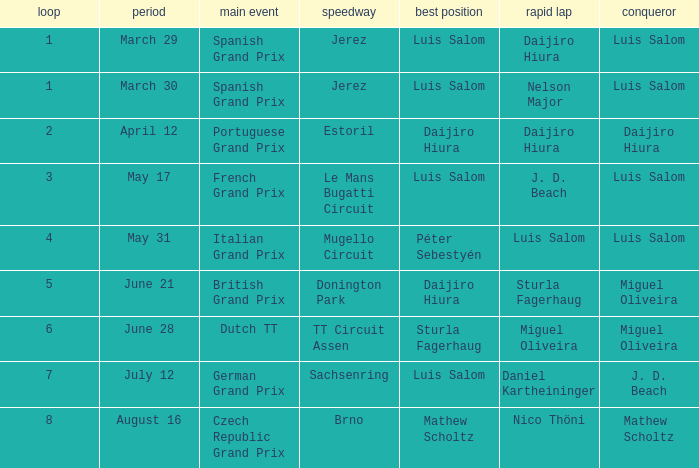What grand prixs did Daijiro Hiura win?  Portuguese Grand Prix. 